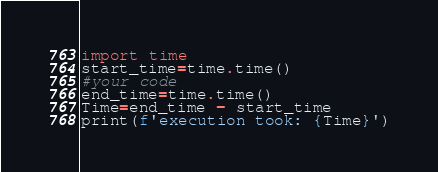<code> <loc_0><loc_0><loc_500><loc_500><_Python_>import time
start_time=time.time()
#your code
end_time=time.time()
Time=end_time - start_time
print(f'execution took: {Time}')</code> 